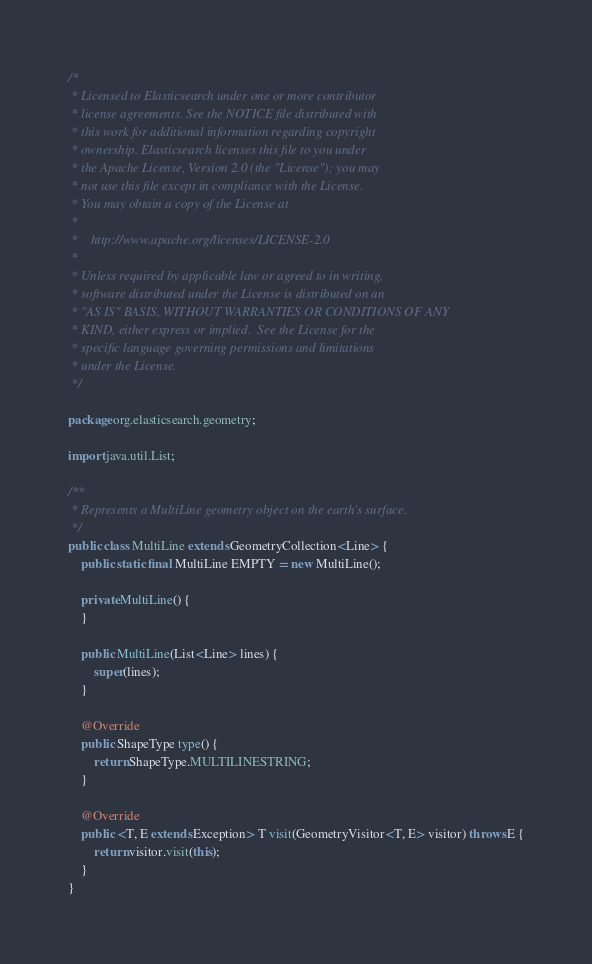Convert code to text. <code><loc_0><loc_0><loc_500><loc_500><_Java_>/*
 * Licensed to Elasticsearch under one or more contributor
 * license agreements. See the NOTICE file distributed with
 * this work for additional information regarding copyright
 * ownership. Elasticsearch licenses this file to you under
 * the Apache License, Version 2.0 (the "License"); you may
 * not use this file except in compliance with the License.
 * You may obtain a copy of the License at
 *
 *    http://www.apache.org/licenses/LICENSE-2.0
 *
 * Unless required by applicable law or agreed to in writing,
 * software distributed under the License is distributed on an
 * "AS IS" BASIS, WITHOUT WARRANTIES OR CONDITIONS OF ANY
 * KIND, either express or implied.  See the License for the
 * specific language governing permissions and limitations
 * under the License.
 */

package org.elasticsearch.geometry;

import java.util.List;

/**
 * Represents a MultiLine geometry object on the earth's surface.
 */
public class MultiLine extends GeometryCollection<Line> {
    public static final MultiLine EMPTY = new MultiLine();

    private MultiLine() {
    }

    public MultiLine(List<Line> lines) {
        super(lines);
    }

    @Override
    public ShapeType type() {
        return ShapeType.MULTILINESTRING;
    }

    @Override
    public <T, E extends Exception> T visit(GeometryVisitor<T, E> visitor) throws E {
        return visitor.visit(this);
    }
}
</code> 